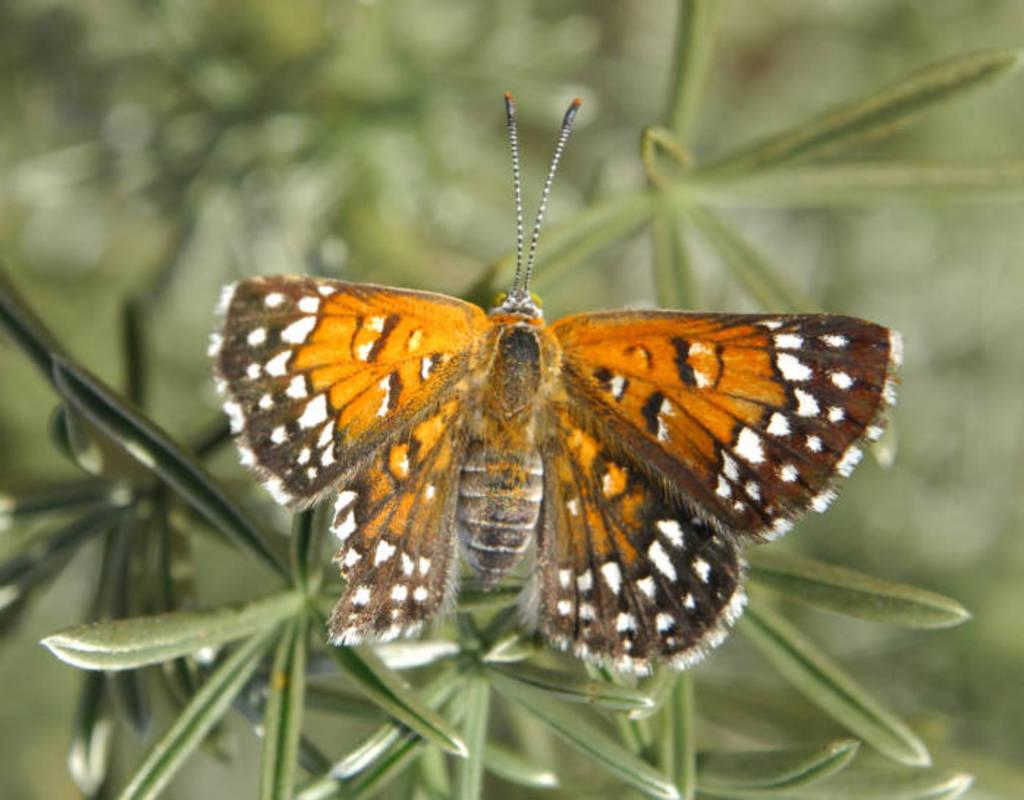What is the main subject of the image? There is a butterfly in the image. Can you describe the colors of the butterfly? The butterfly has brown and orange colors. Where is the butterfly located in the image? The butterfly is on a leaf. What type of plant is the leaf part of? The leaf is part of a plant with green leaves. How would you describe the background of the image? The background of the image is blurred. How many sisters are riding the bike in the image? There is no bike or sisters present in the image; it features a butterfly on a leaf. What is the value of the quarter shown in the image? There is no quarter present in the image; it features a butterfly on a leaf. 